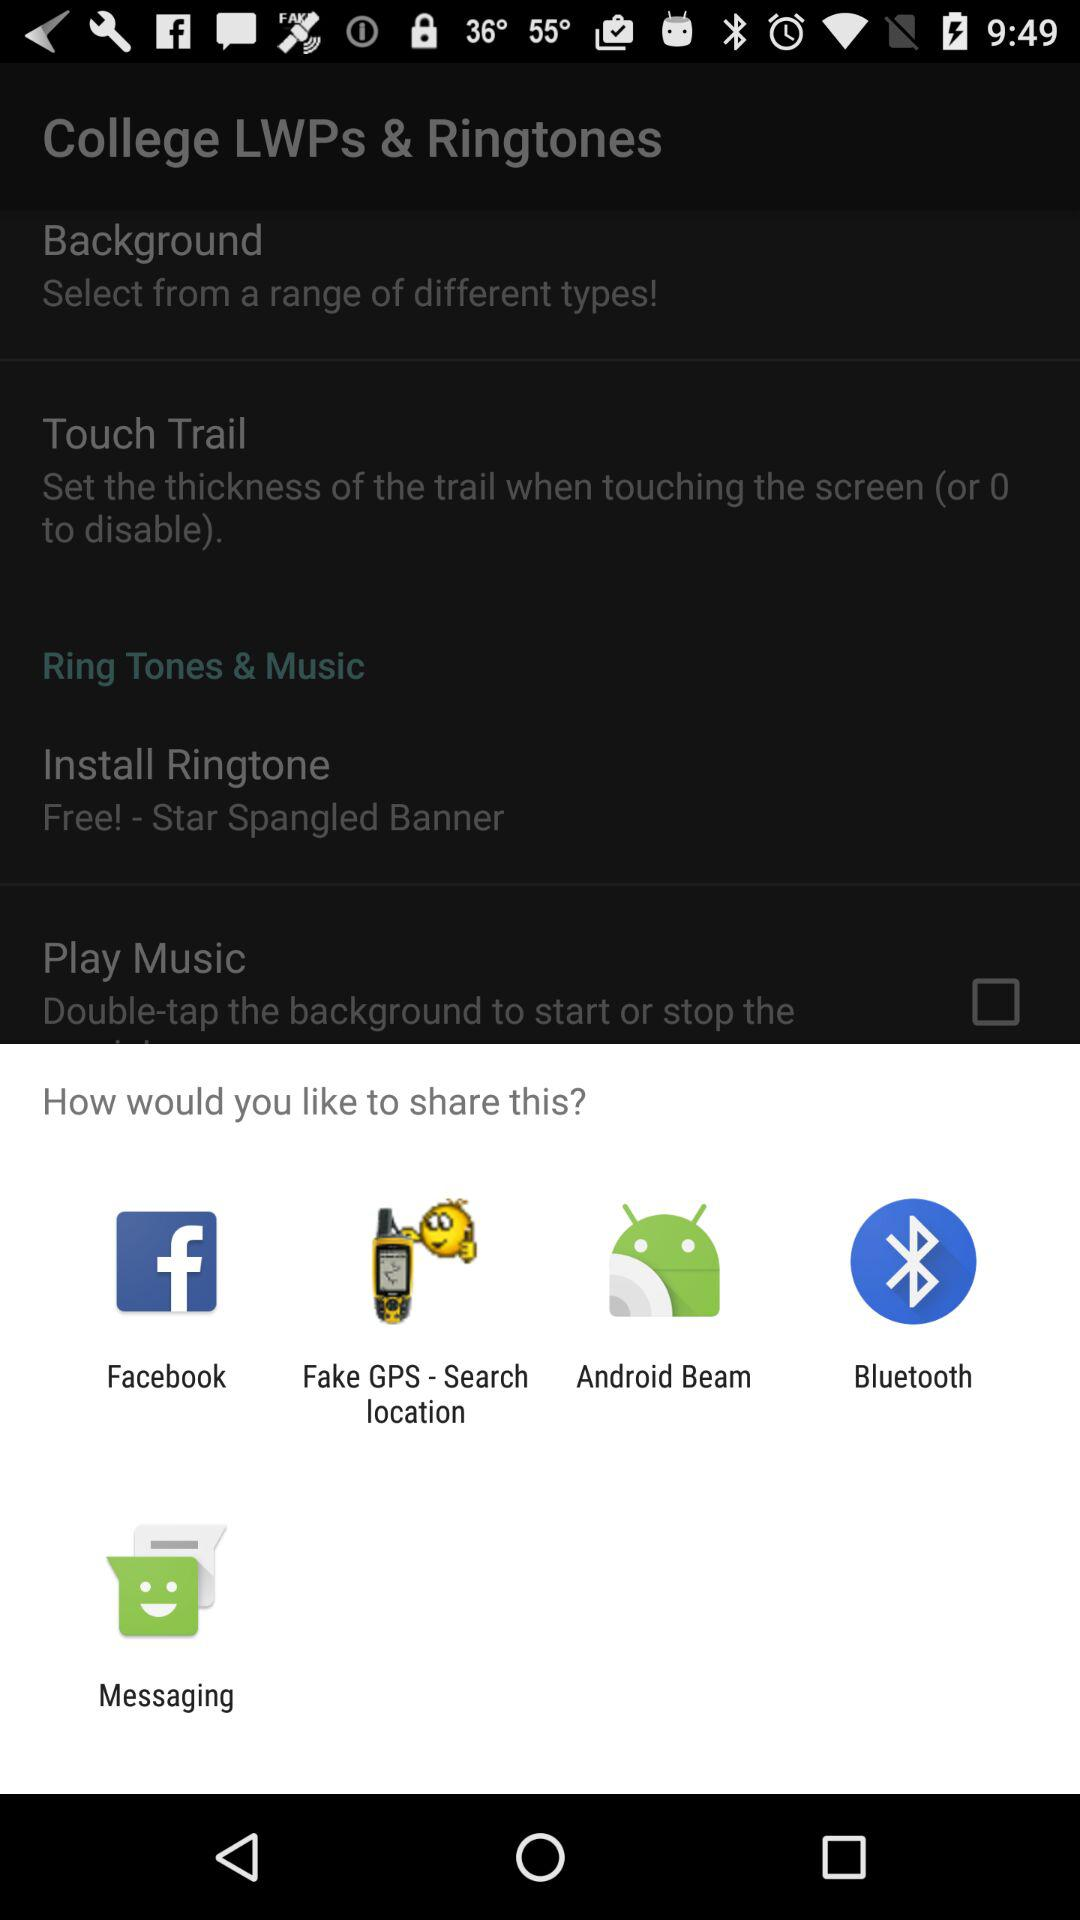Which background was selected?
When the provided information is insufficient, respond with <no answer>. <no answer> 